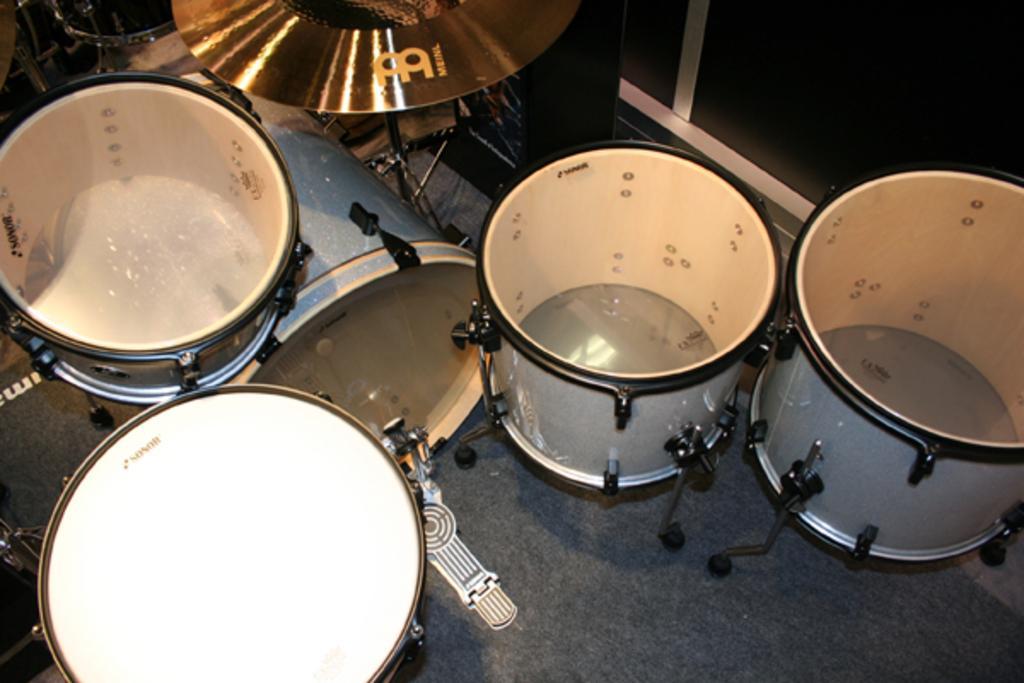How would you summarize this image in a sentence or two? In this image there are some drums kept on the floor as we can see in middle of this image. 